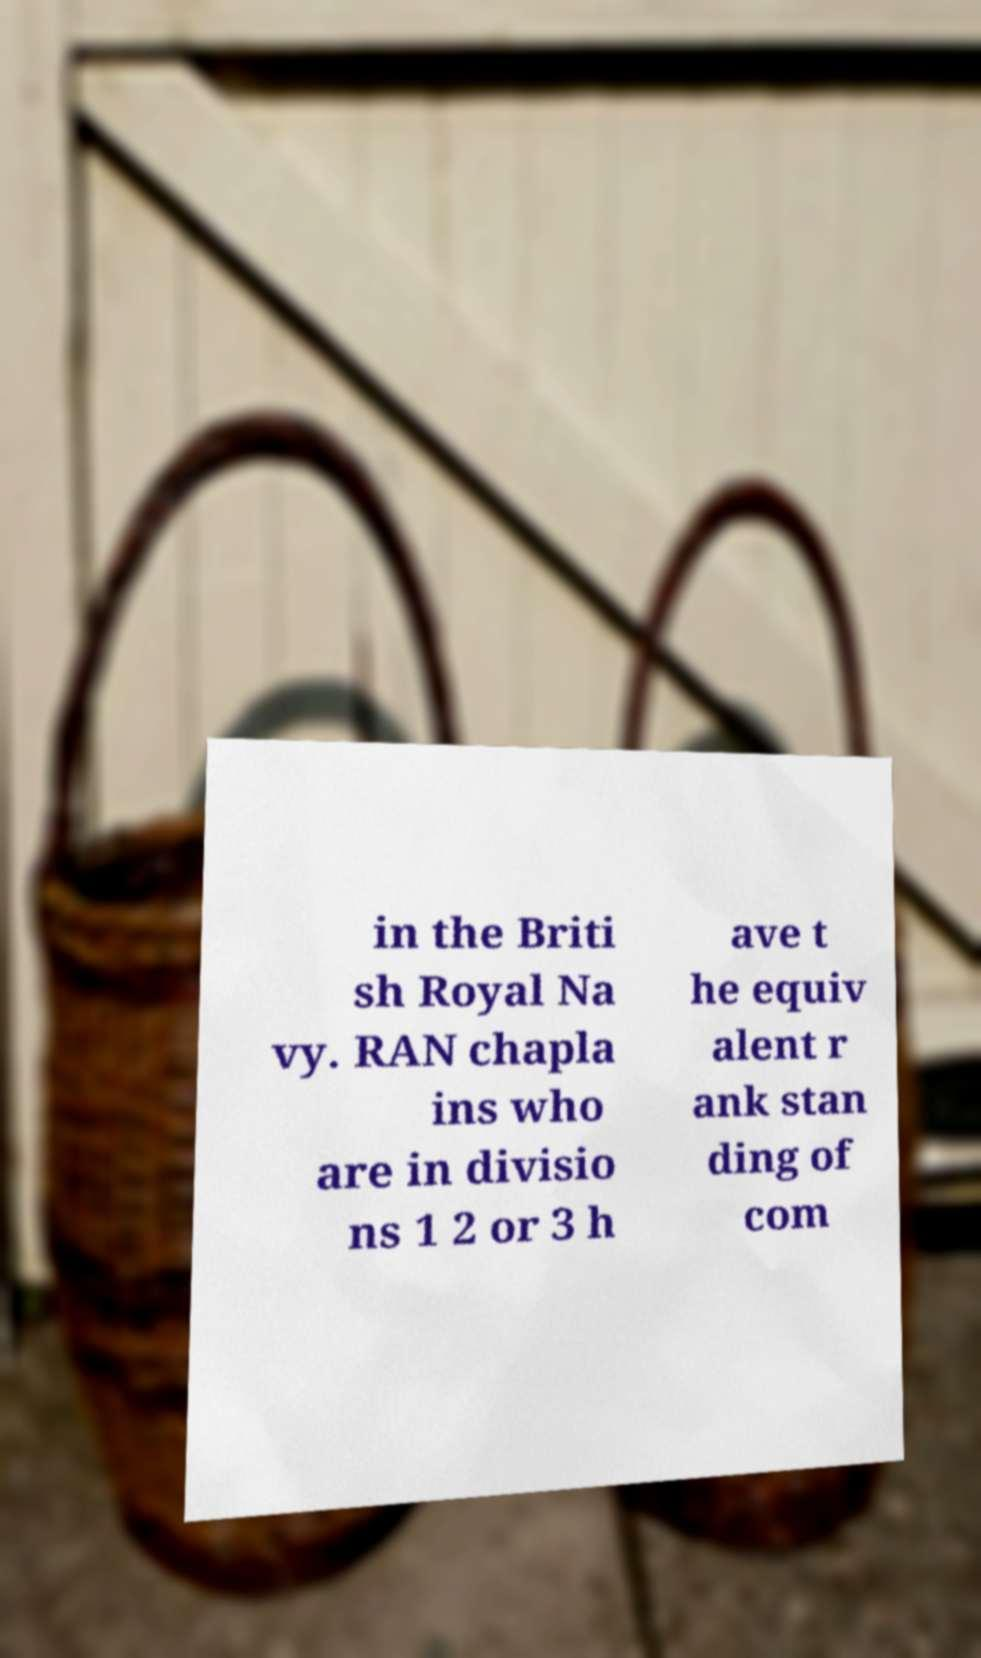There's text embedded in this image that I need extracted. Can you transcribe it verbatim? in the Briti sh Royal Na vy. RAN chapla ins who are in divisio ns 1 2 or 3 h ave t he equiv alent r ank stan ding of com 